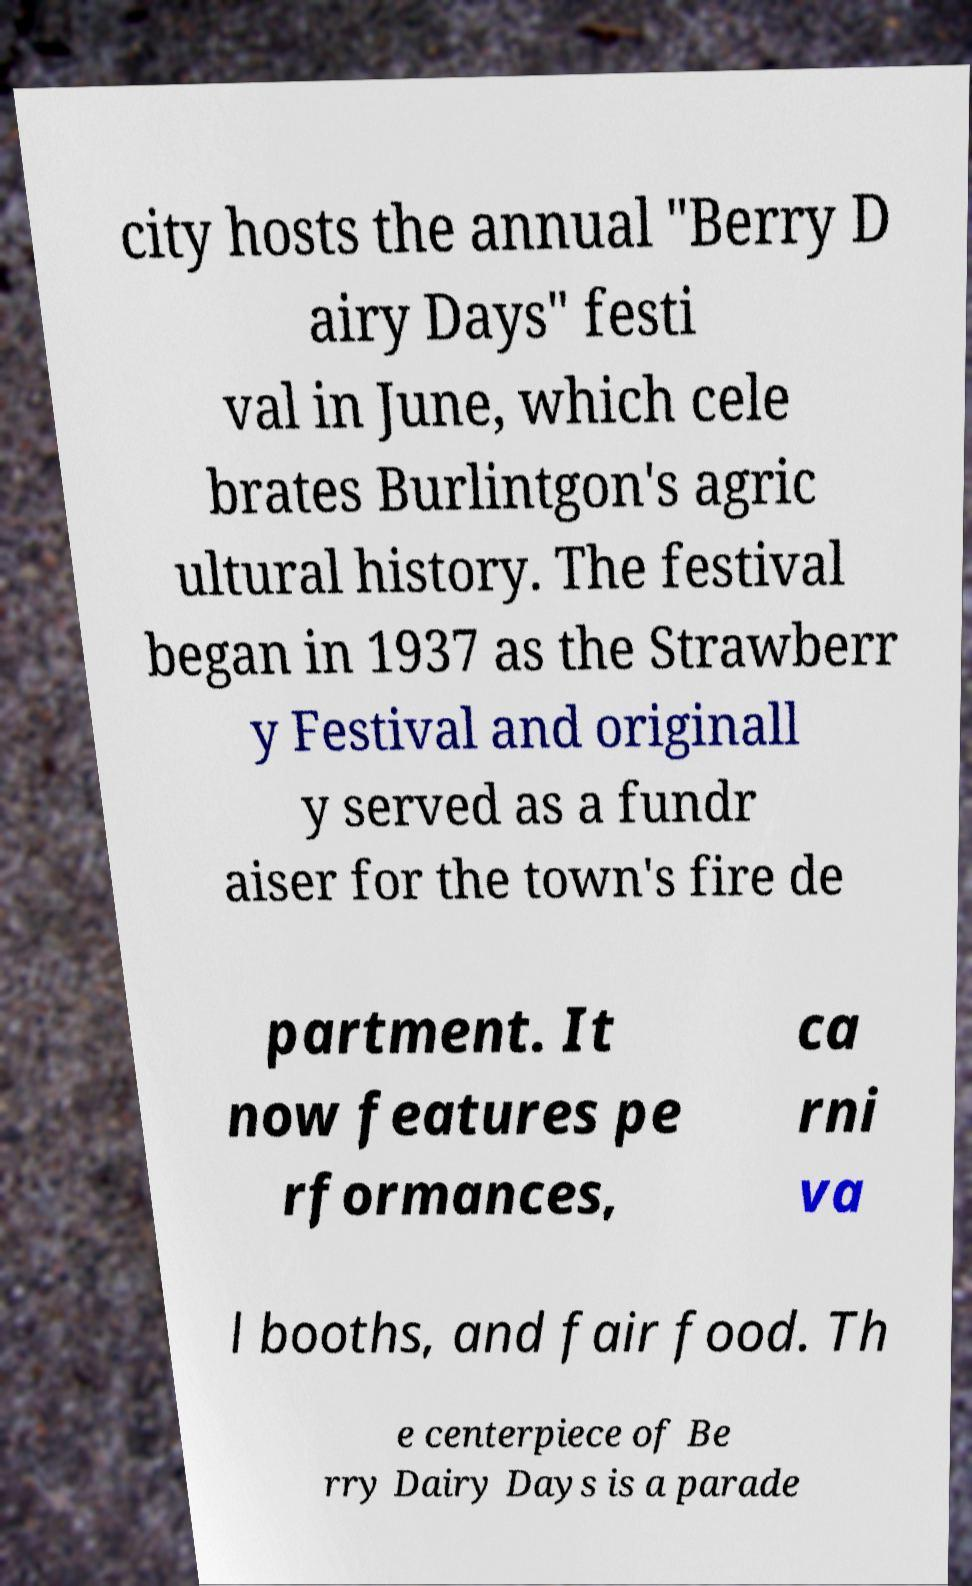There's text embedded in this image that I need extracted. Can you transcribe it verbatim? city hosts the annual "Berry D airy Days" festi val in June, which cele brates Burlintgon's agric ultural history. The festival began in 1937 as the Strawberr y Festival and originall y served as a fundr aiser for the town's fire de partment. It now features pe rformances, ca rni va l booths, and fair food. Th e centerpiece of Be rry Dairy Days is a parade 